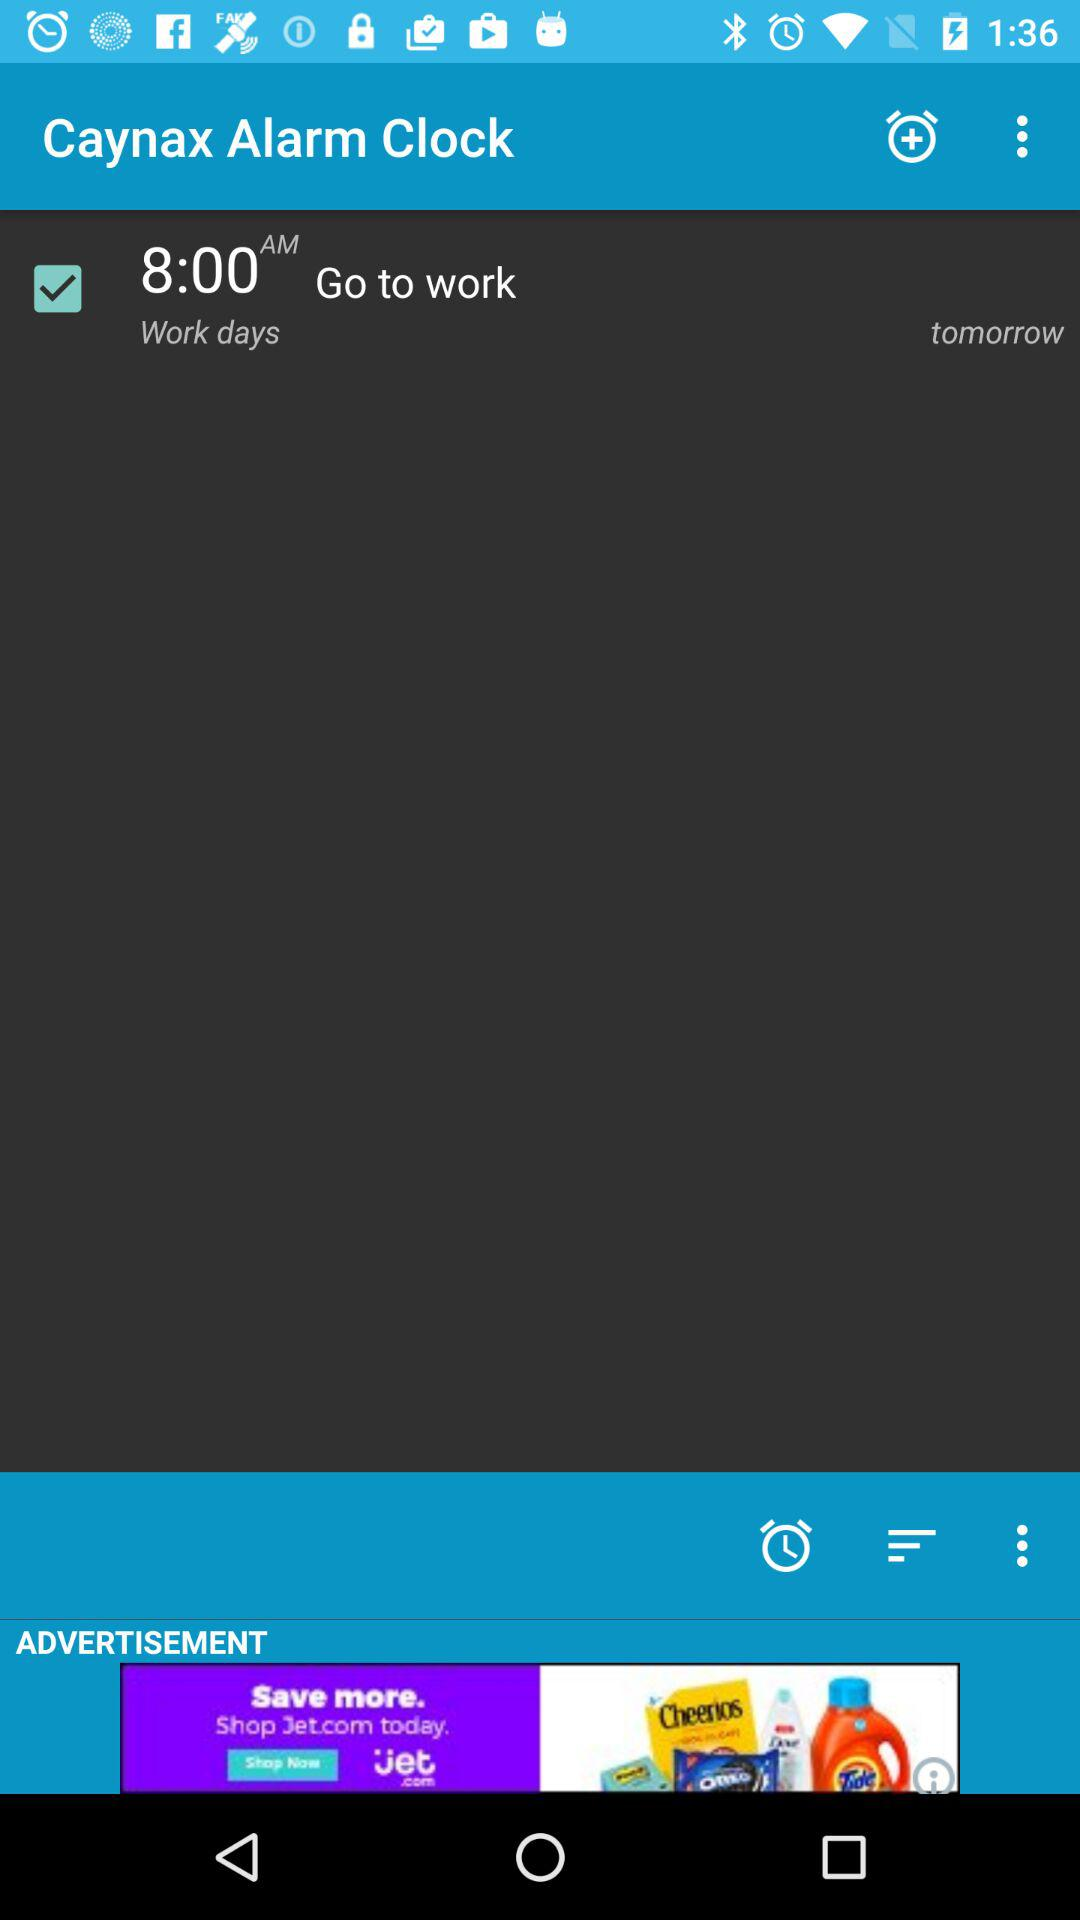What is the time of the alarm?
Answer the question using a single word or phrase. 8:00 AM 